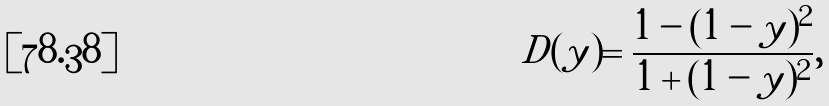Convert formula to latex. <formula><loc_0><loc_0><loc_500><loc_500>D ( y ) = \frac { 1 - ( 1 - y ) ^ { 2 } } { 1 + ( 1 - y ) ^ { 2 } } ,</formula> 